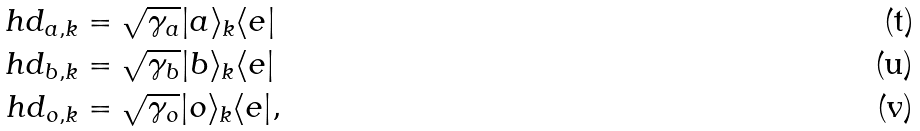Convert formula to latex. <formula><loc_0><loc_0><loc_500><loc_500>\ h d _ { a , k } & = \sqrt { \gamma _ { a } } | a \rangle _ { k } \langle e | \\ \ h d _ { b , k } & = \sqrt { \gamma _ { b } } | b \rangle _ { k } \langle e | \\ \ h d _ { o , k } & = \sqrt { \gamma _ { o } } | o \rangle _ { k } \langle e | ,</formula> 